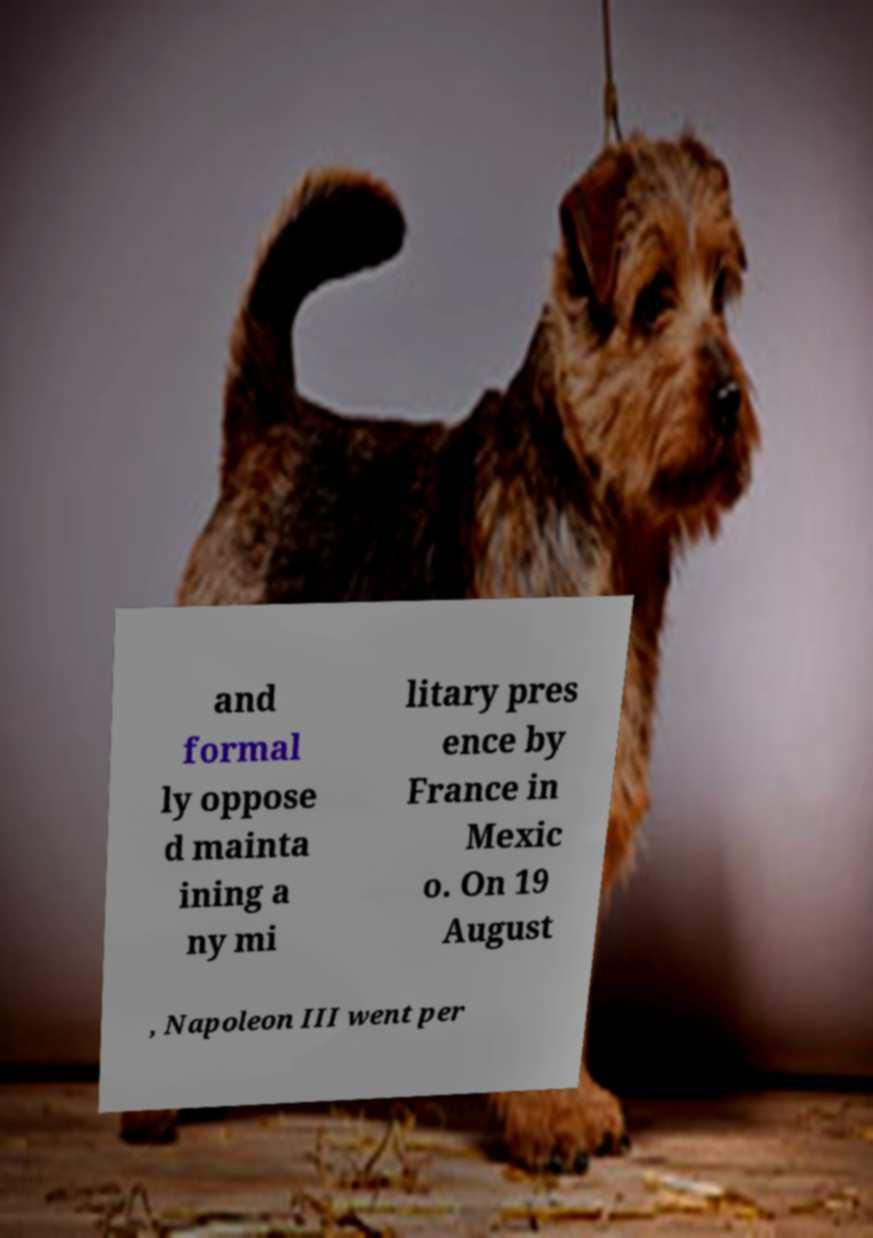What messages or text are displayed in this image? I need them in a readable, typed format. and formal ly oppose d mainta ining a ny mi litary pres ence by France in Mexic o. On 19 August , Napoleon III went per 